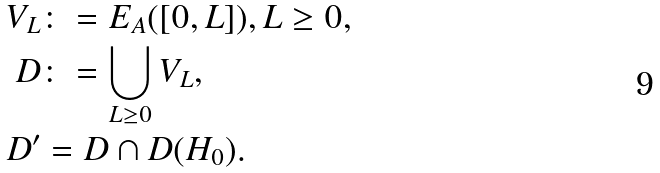Convert formula to latex. <formula><loc_0><loc_0><loc_500><loc_500>V _ { L } & \colon = E _ { A } ( [ 0 , L ] ) , L \geq 0 , \\ D & \colon = \bigcup _ { L \geq 0 } V _ { L } , \\ D ^ { \prime } & = D \cap D ( H _ { 0 } ) .</formula> 